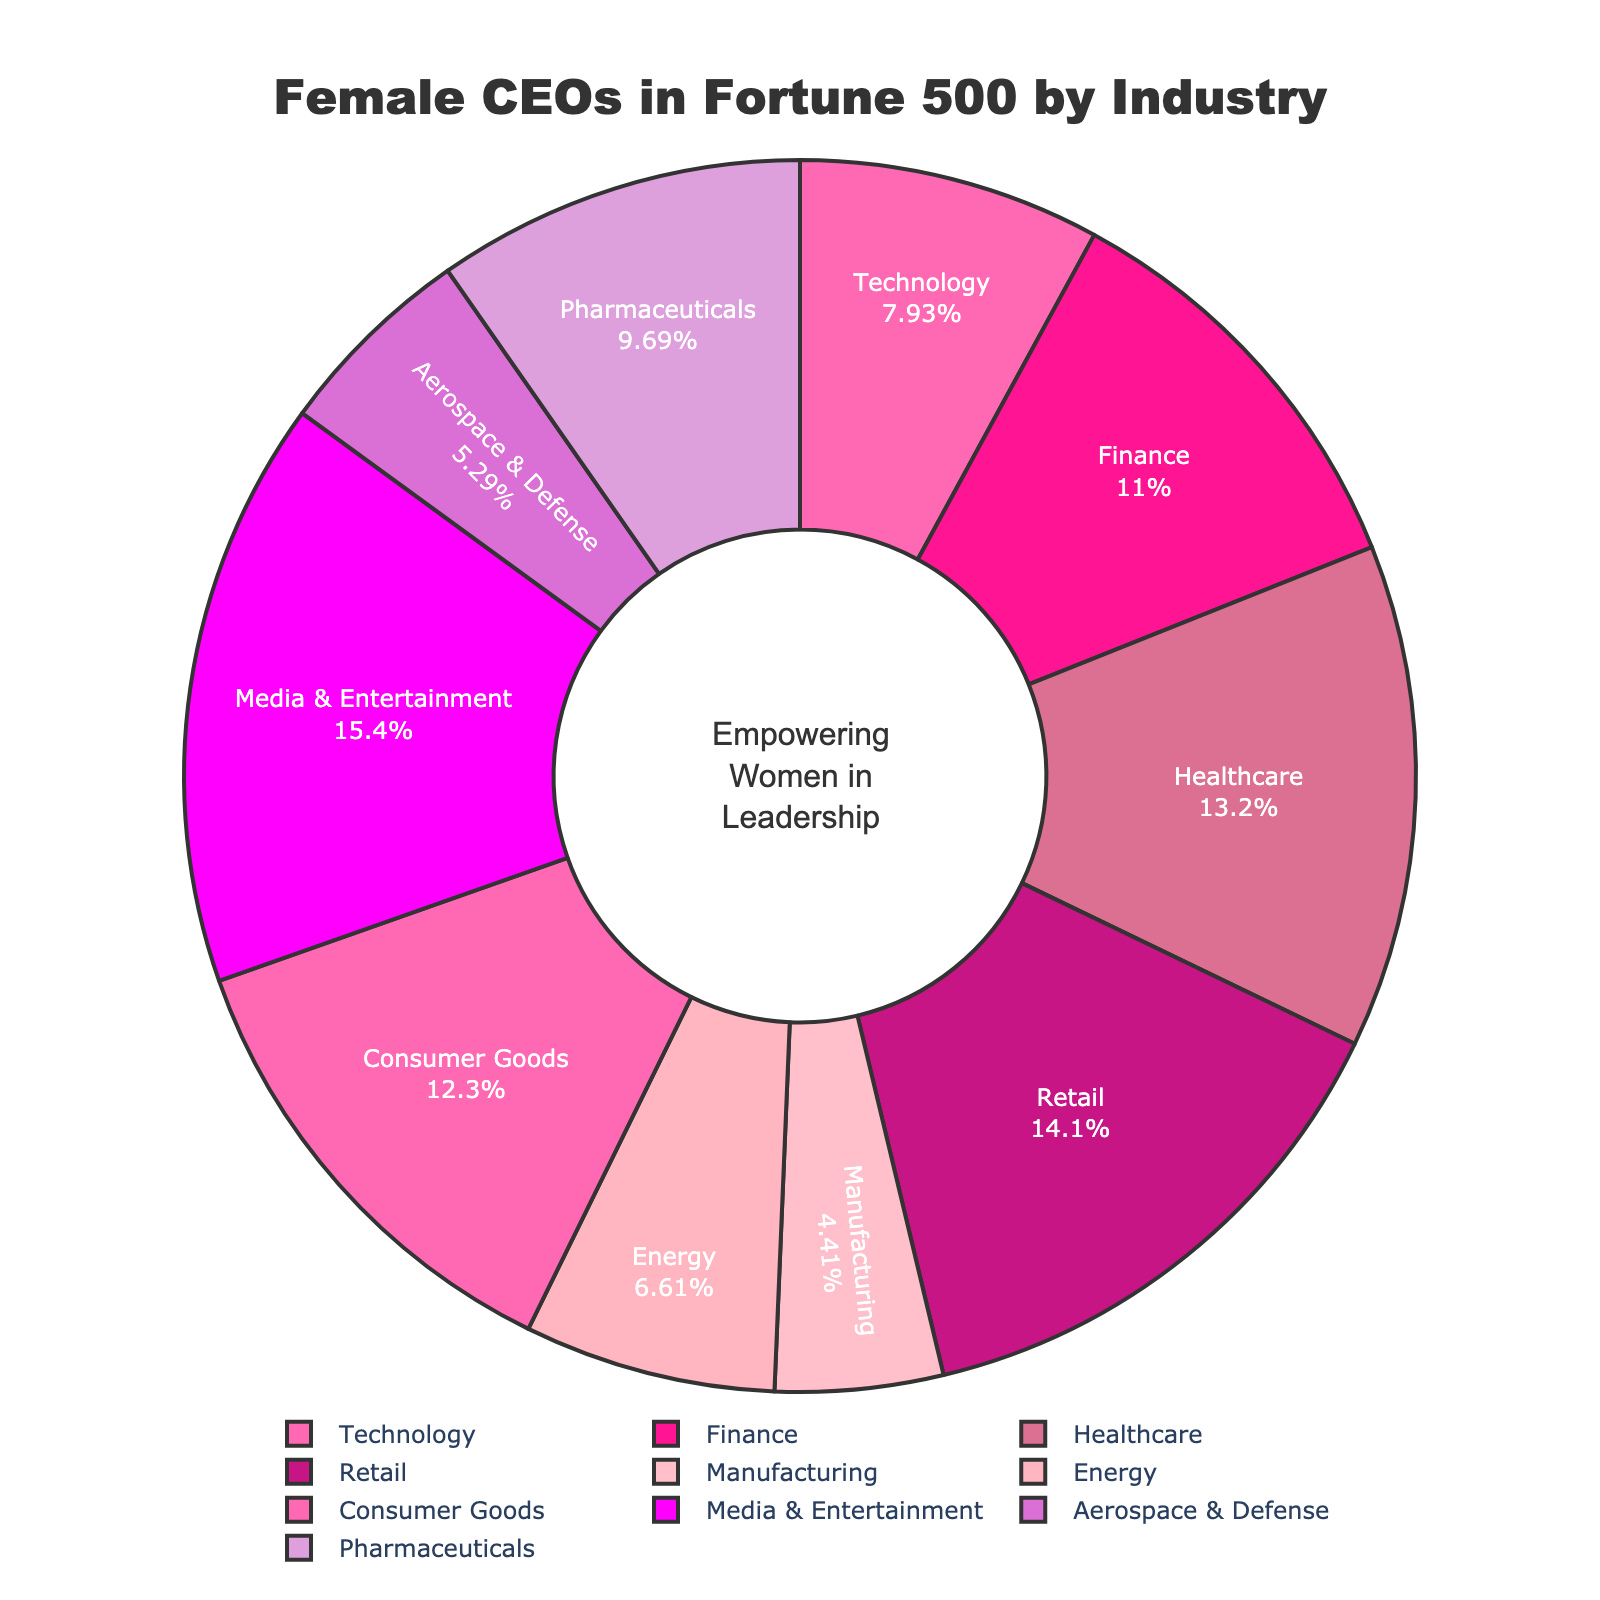What percentage of Fortune 500 CEOs in the Technology industry are female? To determine the percentage of female CEOs in the Technology industry, locate the Technology section of the pie chart and read the percentage value displayed.
Answer: 18% Which industry has the highest proportion of female CEOs, and what is that percentage? Examine the pie chart and identify the sector with the largest section marked by the corresponding percentage value. The Media & Entertainment sector shows the highest proportion at 35%.
Answer: Media & Entertainment, 35% Compare the proportion of female CEOs in Healthcare and Manufacturing. Which industry has a higher percentage, and by how much? Locate the Healthcare and Manufacturing sections in the pie chart. Healthcare is shown at 30%, while Manufacturing is at 10%. The difference is calculated as 30% - 10% = 20%.
Answer: Healthcare, 20% What is the total percentage of female CEOs in the Finance and Consumer Goods industries combined? Sum the percentages of Female CEOs in the Finance (25%) and Consumer Goods (28%) industries: 25% + 28% = 53%.
Answer: 53% Are there more female CEOs in the Aerospace & Defense industry or the Energy industry, and by what percentage difference? Check the percentages for Aerospace & Defense (12%) and Energy (15%) in the pie chart. The percentage difference is 15% - 12% = 3%.
Answer: Energy, 3% Which industry has the lowest representation of female CEOs, and what is that percentage? Identify the smallest section in the pie chart, indicating the industry with the lowest percentage. Manufacturing has the lowest representation at 10%.
Answer: Manufacturing, 10% How do the percentages of female CEOs in the Technology and Pharmaceuticals industries compare? Locate the percentages for Technology (18%) and Pharmaceuticals (22%) on the pie chart. Pharmaceuticals have a 4% higher representation than Technology.
Answer: Pharmaceuticals, 4% What is the combined percentage of female CEOs in the Technology and Aerospace & Defense industries? Sum the percentages of female CEOs in the Technology (18%) and Aerospace & Defense (12%) industries: 18% + 12% = 30%.
Answer: 30% Given the distributions, which industry shows significantly higher female CEO representation compared to Energy, and what is the percentage difference? Identify an industry with a notably higher percentage than Energy at 15%. Media & Entertainment is 35%, a difference of 35% - 15% = 20%.
Answer: Media & Entertainment, 20% What is the approximate average percentage of female CEOs across all listed industries? To find the average, sum the percentages of female CEOs across all 10 industries and divide by 10. The percentages are: 18%, 25%, 30%, 32%, 10%, 15%, 28%, 35%, 12%, 22%. Sum = 227%. Average = 227% / 10 = 22.7%.
Answer: 22.7% 